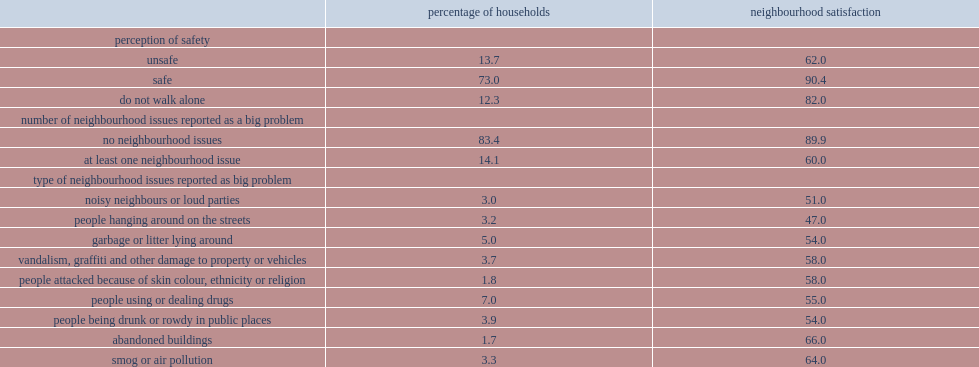How many percent of households indicated that they felt unsafe from crime walking alone after dark in their neighbourhood? 13.7. Among these households, how many percent were satisfied with their neighbourhood? 62.0. Among other households, how many percent were satisfied with their neighbourhood? 90.4. How many percent of households reported at least one neighbourhood issue as a "big problem"? 14.1. Among these households, how many percent were satisfied with their neighbourhood? 60.0. How many percent for households that did not reported any big problems? 89.9. Among these households, how many percent were satisfied with their neighbourhood? 60.0. How many percent for households that did not reported any big problems? 89.9. Write the full table. {'header': ['', 'percentage of households', 'neighbourhood satisfaction'], 'rows': [['perception of safety', '', ''], ['unsafe', '13.7', '62.0'], ['safe', '73.0', '90.4'], ['do not walk alone', '12.3', '82.0'], ['number of neighbourhood issues reported as a big problem', '', ''], ['no neighbourhood issues', '83.4', '89.9'], ['at least one neighbourhood issue', '14.1', '60.0'], ['type of neighbourhood issues reported as big problem', '', ''], ['noisy neighbours or loud parties', '3.0', '51.0'], ['people hanging around on the streets', '3.2', '47.0'], ['garbage or litter lying around', '5.0', '54.0'], ['vandalism, graffiti and other damage to property or vehicles', '3.7', '58.0'], ['people attacked because of skin colour, ethnicity or religion', '1.8', '58.0'], ['people using or dealing drugs', '7.0', '55.0'], ['people being drunk or rowdy in public places', '3.9', '54.0'], ['abandoned buildings', '1.7', '66.0'], ['smog or air pollution', '3.3', '64.0']]} 